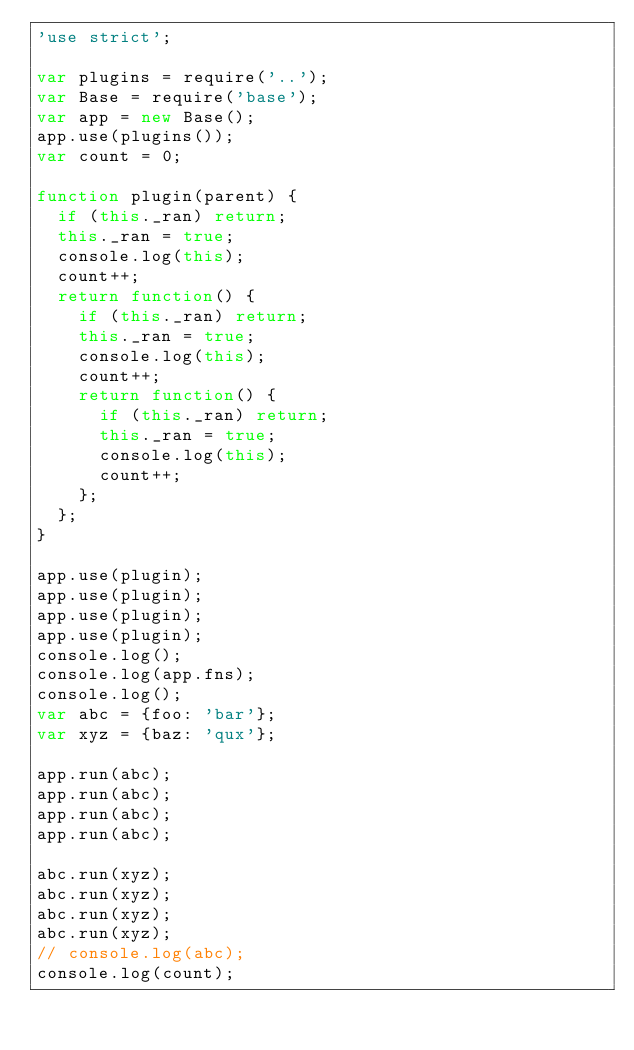Convert code to text. <code><loc_0><loc_0><loc_500><loc_500><_JavaScript_>'use strict';

var plugins = require('..');
var Base = require('base');
var app = new Base();
app.use(plugins());
var count = 0;

function plugin(parent) {
  if (this._ran) return;
  this._ran = true;
  console.log(this);
  count++;
  return function() {
    if (this._ran) return;
    this._ran = true;
    console.log(this);
    count++;
    return function() {
      if (this._ran) return;
      this._ran = true;
      console.log(this);
      count++;
    };
  };
}

app.use(plugin);
app.use(plugin);
app.use(plugin);
app.use(plugin);
console.log();
console.log(app.fns);
console.log();
var abc = {foo: 'bar'};
var xyz = {baz: 'qux'};

app.run(abc);
app.run(abc);
app.run(abc);
app.run(abc);

abc.run(xyz);
abc.run(xyz);
abc.run(xyz);
abc.run(xyz);
// console.log(abc);
console.log(count);
</code> 